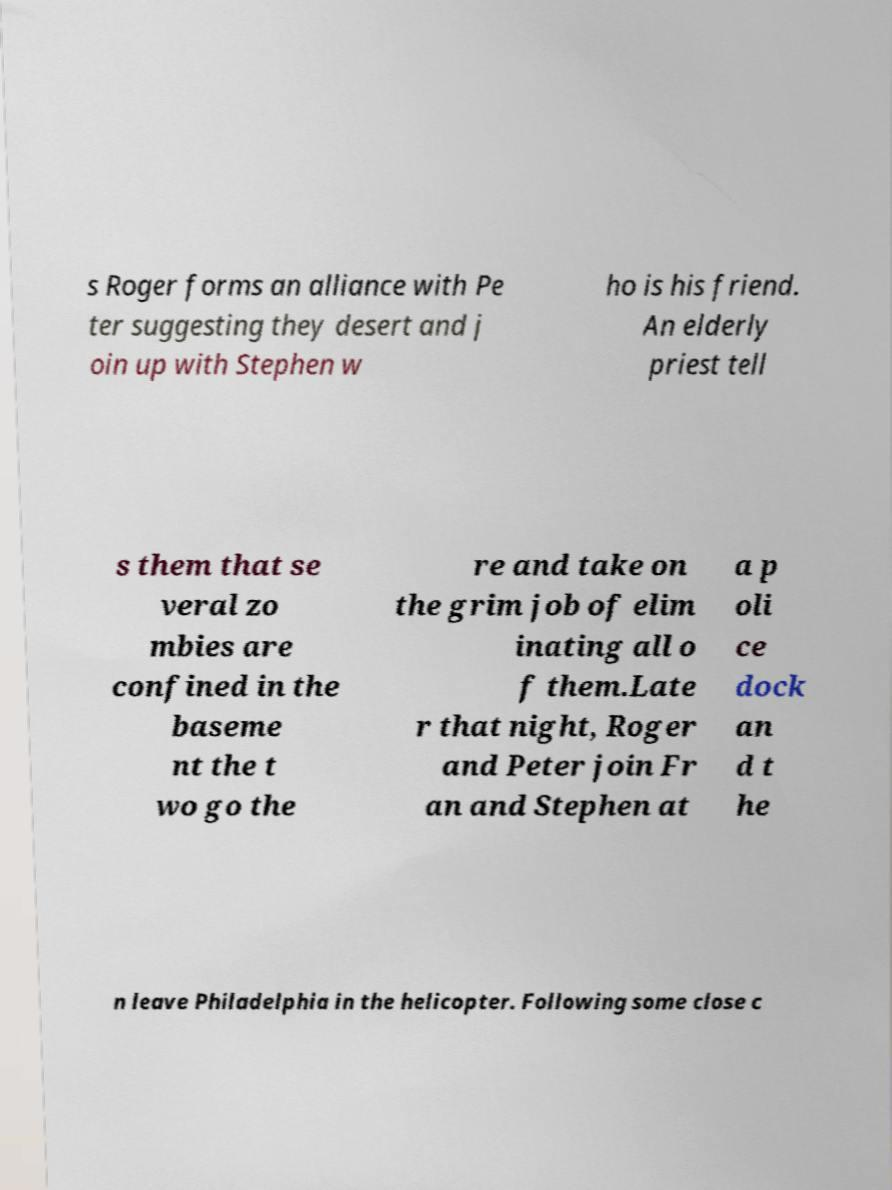There's text embedded in this image that I need extracted. Can you transcribe it verbatim? s Roger forms an alliance with Pe ter suggesting they desert and j oin up with Stephen w ho is his friend. An elderly priest tell s them that se veral zo mbies are confined in the baseme nt the t wo go the re and take on the grim job of elim inating all o f them.Late r that night, Roger and Peter join Fr an and Stephen at a p oli ce dock an d t he n leave Philadelphia in the helicopter. Following some close c 